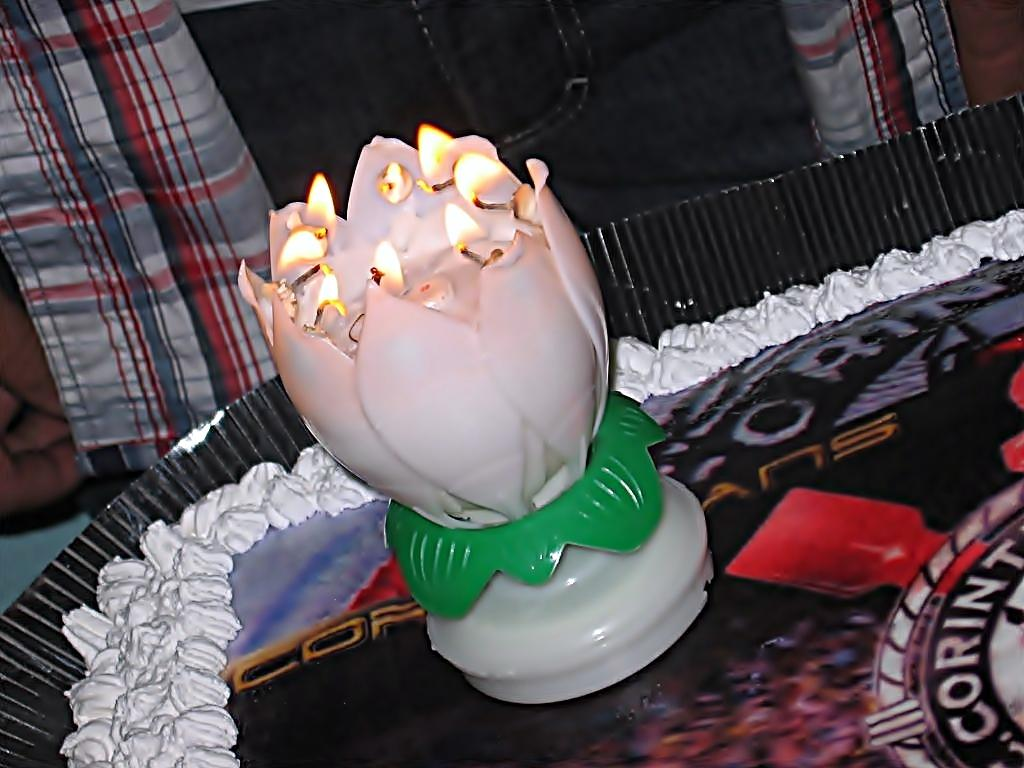What is the main object in the image? There is a white collar device in the image. What can be observed about the design of the device? The device has flame lights arranged on its surface. Where is the device located? The device is on a cake. Can you describe the presence of any other people in the image? There is a person in the background of the image. How many girls are holding copper impulse devices in the image? There are no girls or copper impulse devices present in the image. 